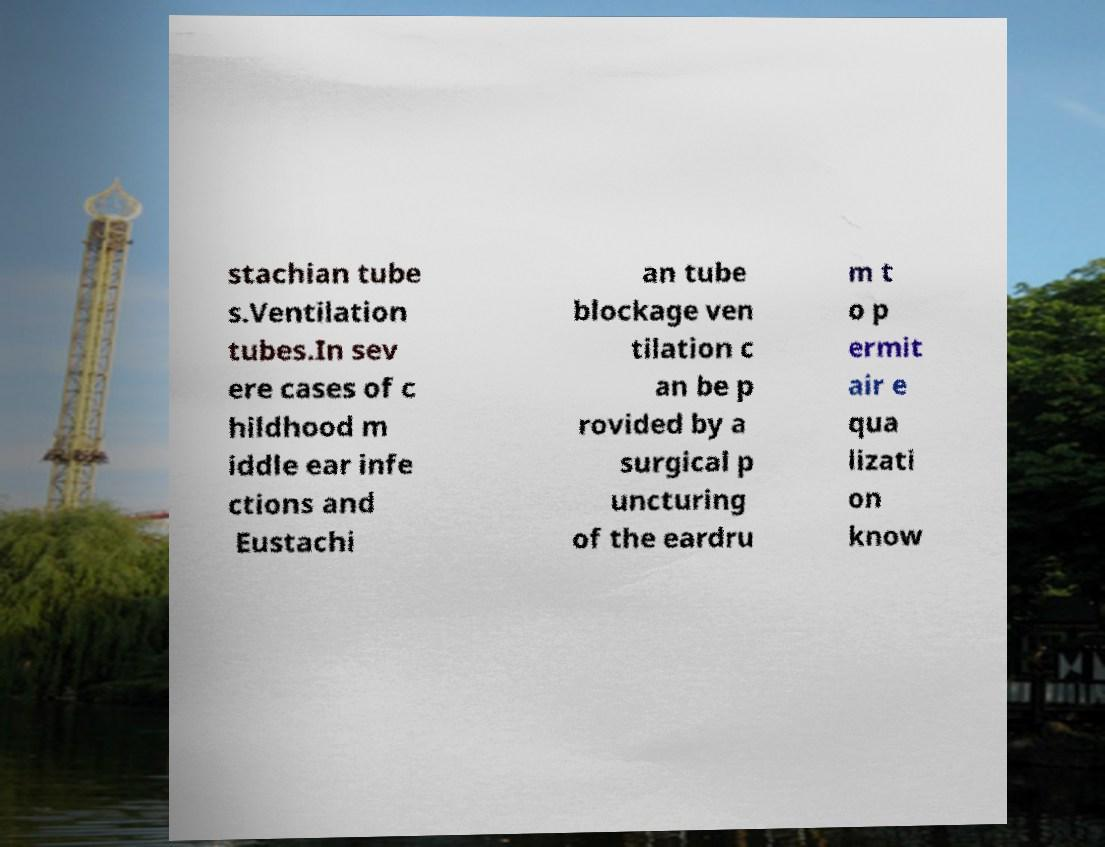What messages or text are displayed in this image? I need them in a readable, typed format. stachian tube s.Ventilation tubes.In sev ere cases of c hildhood m iddle ear infe ctions and Eustachi an tube blockage ven tilation c an be p rovided by a surgical p uncturing of the eardru m t o p ermit air e qua lizati on know 